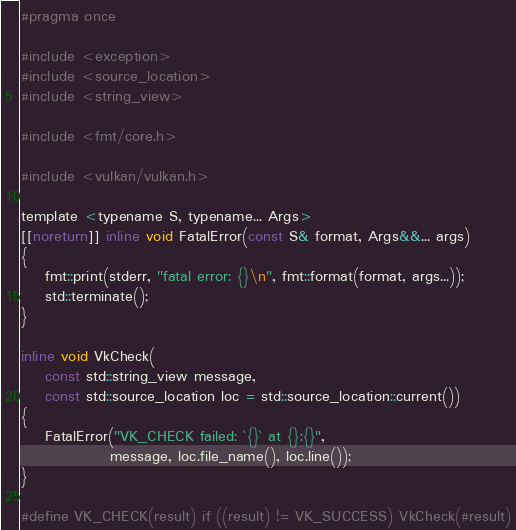<code> <loc_0><loc_0><loc_500><loc_500><_C_>#pragma once

#include <exception>
#include <source_location>
#include <string_view>

#include <fmt/core.h>

#include <vulkan/vulkan.h>

template <typename S, typename... Args>
[[noreturn]] inline void FatalError(const S& format, Args&&... args)
{
	fmt::print(stderr, "fatal error: {}\n", fmt::format(format, args...));
	std::terminate();
}

inline void VkCheck(
	const std::string_view message,
	const std::source_location loc = std::source_location::current())
{
	FatalError("VK_CHECK failed: `{}` at {}:{}",
		       message, loc.file_name(), loc.line());
}

#define VK_CHECK(result) if ((result) != VK_SUCCESS) VkCheck(#result)</code> 